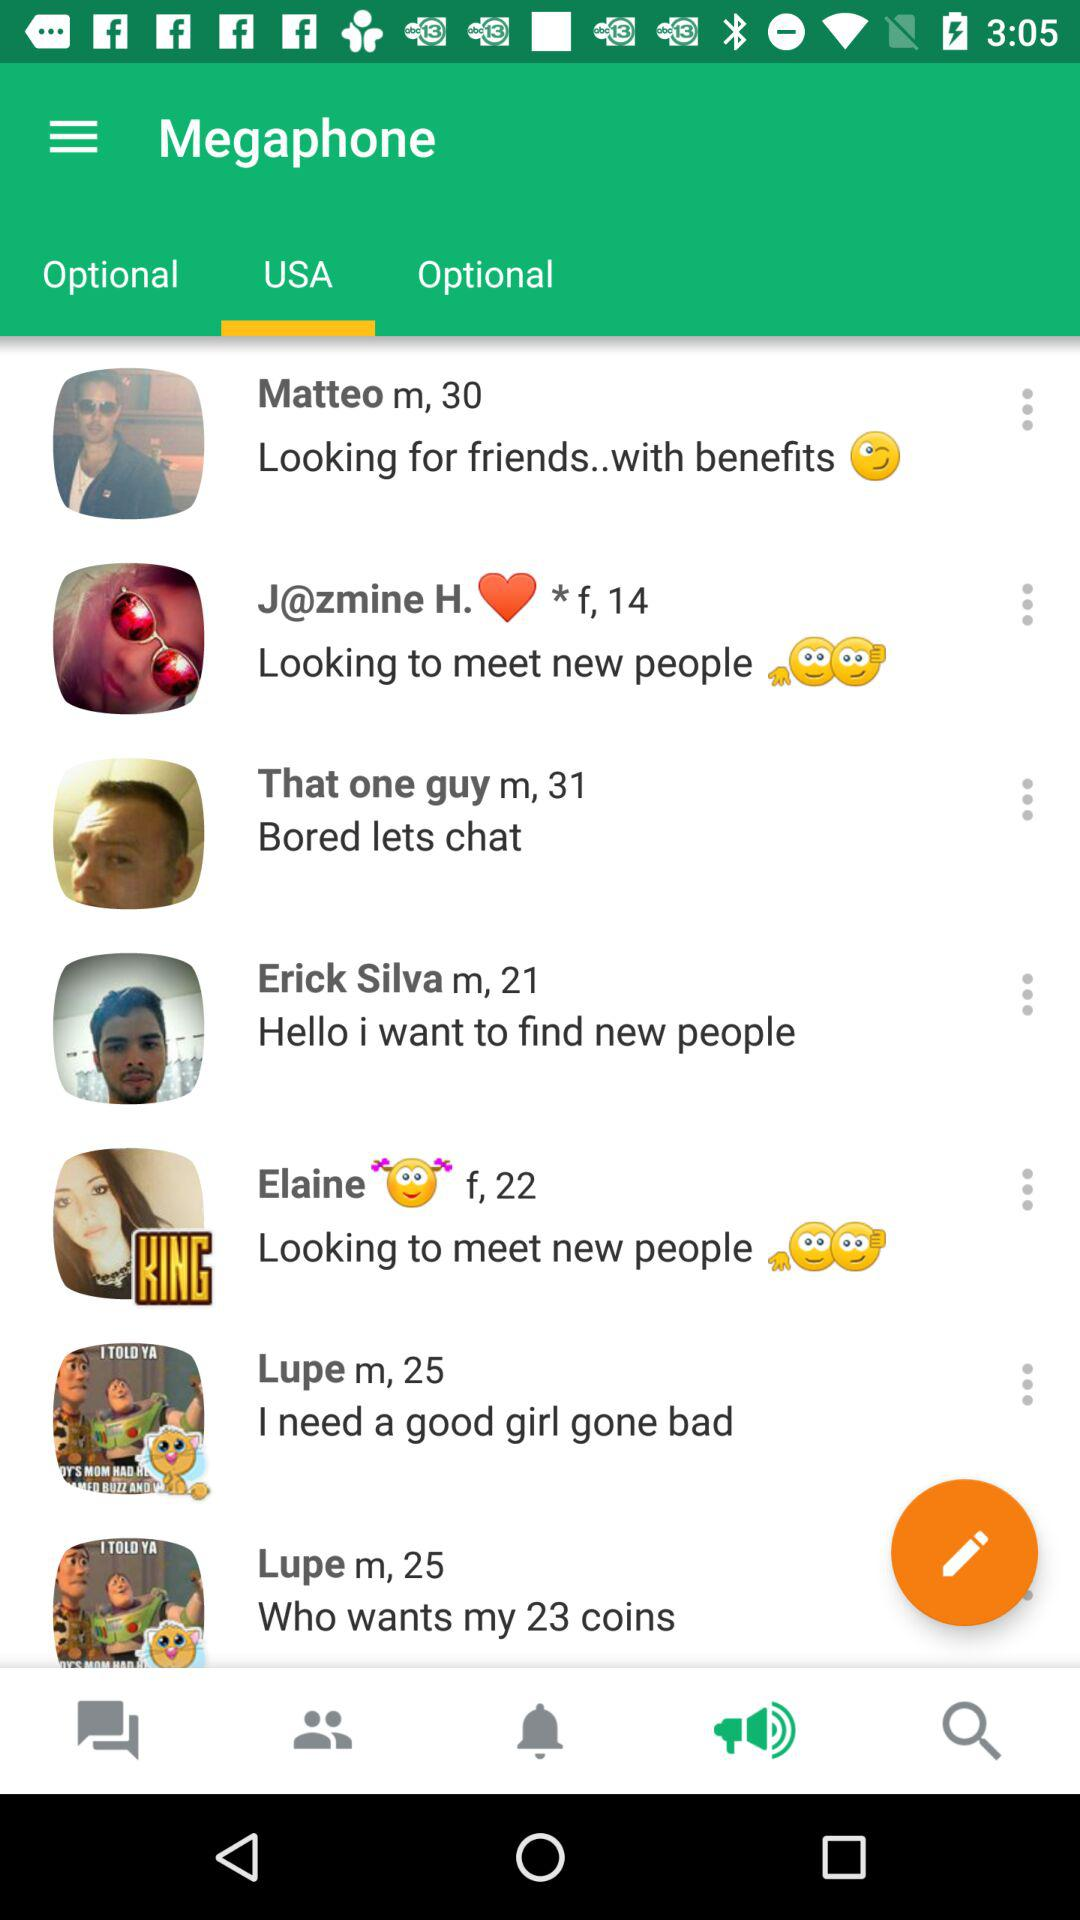What is the gender of Elaine? The gender of Elaine is female. 